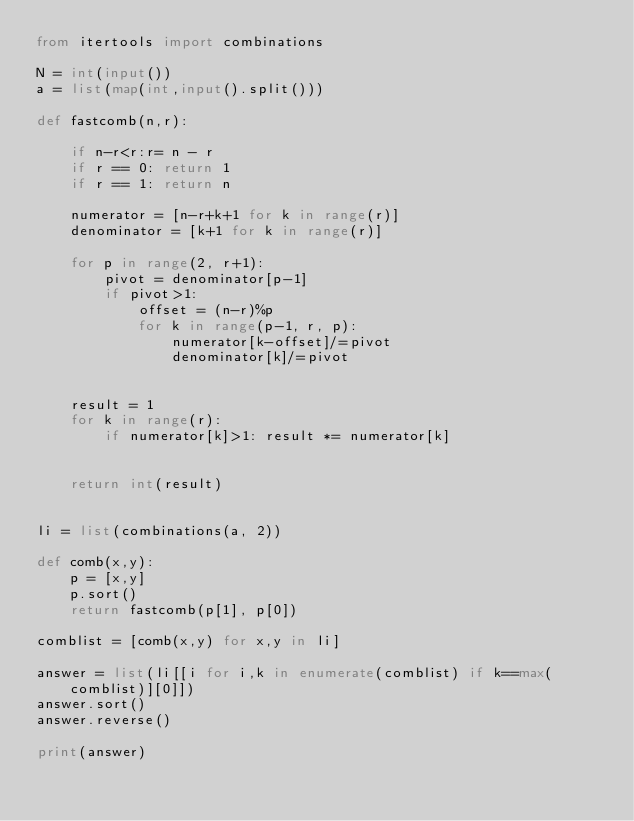Convert code to text. <code><loc_0><loc_0><loc_500><loc_500><_Python_>from itertools import combinations

N = int(input())
a = list(map(int,input().split()))

def fastcomb(n,r):
    
    if n-r<r:r= n - r
    if r == 0: return 1
    if r == 1: return n

    numerator = [n-r+k+1 for k in range(r)]
    denominator = [k+1 for k in range(r)]
    
    for p in range(2, r+1):
        pivot = denominator[p-1]
        if pivot>1:
            offset = (n-r)%p
            for k in range(p-1, r, p):
                numerator[k-offset]/=pivot
                denominator[k]/=pivot
    

    result = 1
    for k in range(r):
        if numerator[k]>1: result *= numerator[k]


    return int(result)


li = list(combinations(a, 2))

def comb(x,y):
    p = [x,y]
    p.sort()
    return fastcomb(p[1], p[0])
    
comblist = [comb(x,y) for x,y in li]

answer = list(li[[i for i,k in enumerate(comblist) if k==max(comblist)][0]])
answer.sort()
answer.reverse()

print(answer)</code> 